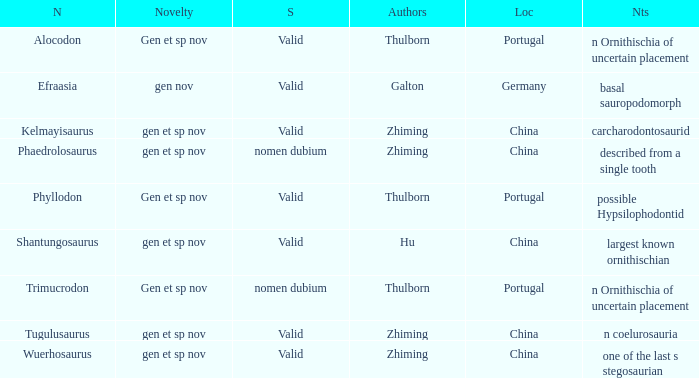What is the Name of the dinosaur, whose notes are, "n ornithischia of uncertain placement"? Alocodon, Trimucrodon. 